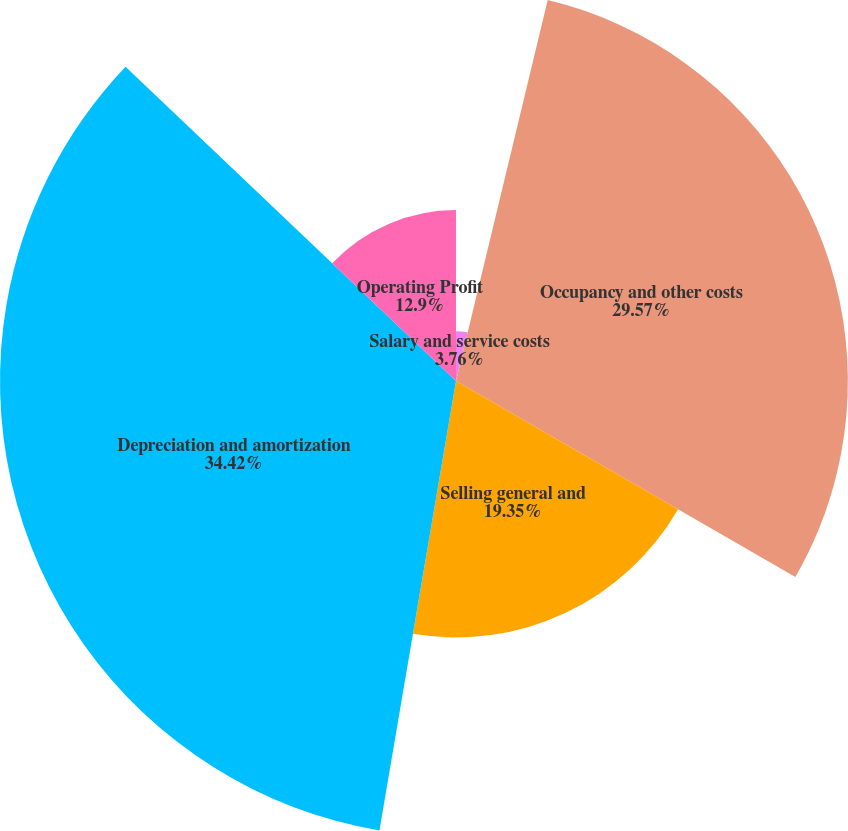Convert chart. <chart><loc_0><loc_0><loc_500><loc_500><pie_chart><fcel>Salary and service costs<fcel>Occupancy and other costs<fcel>Selling general and<fcel>Depreciation and amortization<fcel>Operating Profit<nl><fcel>3.76%<fcel>29.57%<fcel>19.35%<fcel>34.41%<fcel>12.9%<nl></chart> 